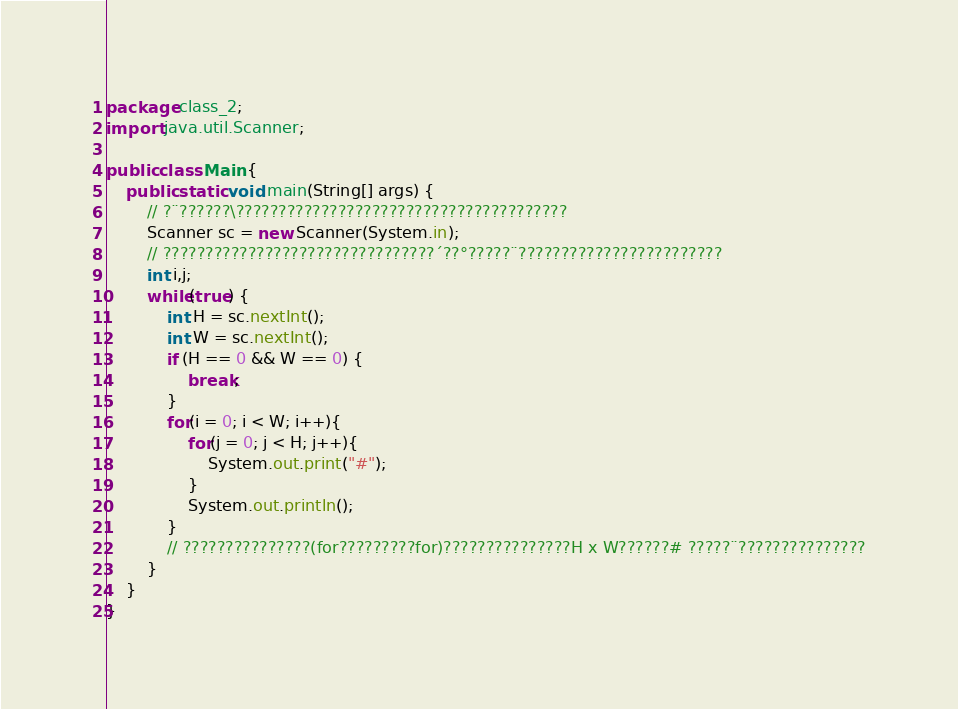Convert code to text. <code><loc_0><loc_0><loc_500><loc_500><_Java_>package class_2;
import java.util.Scanner;

public class Main {
	public static void main(String[] args) {
		// ?¨??????\???????????????????????????????????????
		Scanner sc = new Scanner(System.in);
		// ????????????????????????????????´??°?????¨????????????????????????
		int i,j;
		while(true) {
			int H = sc.nextInt();
			int W = sc.nextInt();
			if (H == 0 && W == 0) {
				break;
			}
			for(i = 0; i < W; i++){
				for(j = 0; j < H; j++){
					System.out.print("#");
				}
				System.out.println();
			}
			// ???????????????(for?????????for)???????????????H x W??????# ?????¨???????????????
		}
	}
}</code> 